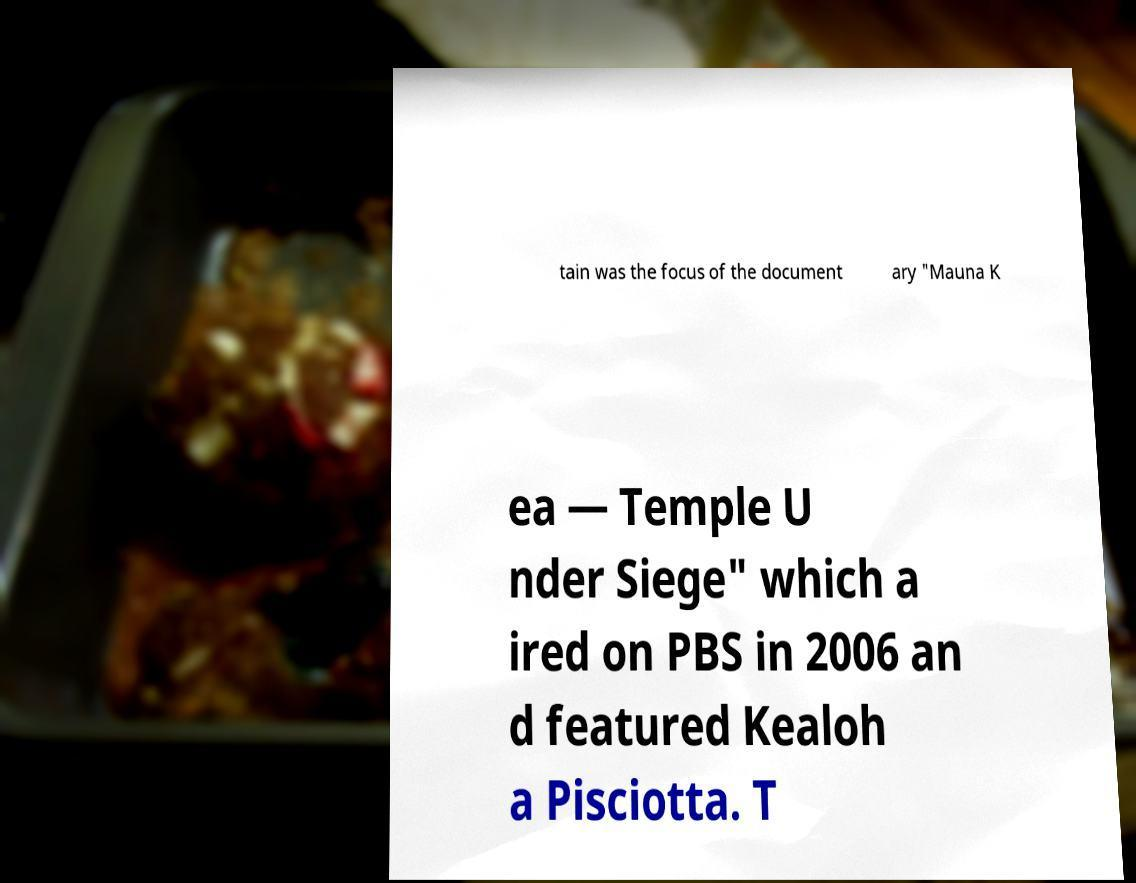I need the written content from this picture converted into text. Can you do that? tain was the focus of the document ary "Mauna K ea — Temple U nder Siege" which a ired on PBS in 2006 an d featured Kealoh a Pisciotta. T 